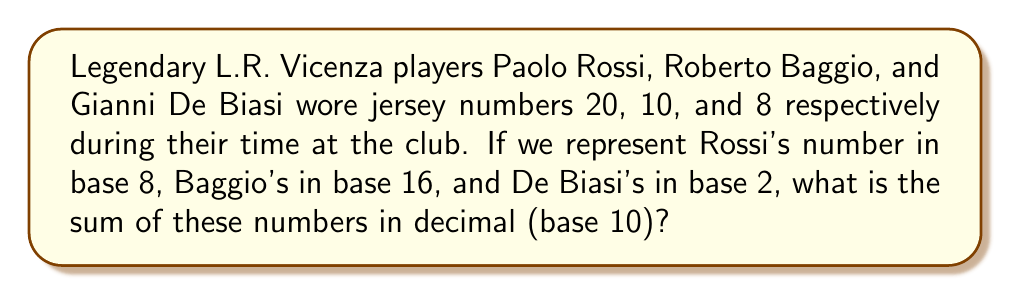Help me with this question. Let's convert each player's jersey number to base 10 and then sum them up:

1. Paolo Rossi's number 20 in base 8:
   $20_8 = 2 \times 8^1 + 0 \times 8^0 = 16_{10}$

2. Roberto Baggio's number 10 in base 16:
   $10_{16} = 1 \times 16^1 + 0 \times 16^0 = 16_{10}$

3. Gianni De Biasi's number 8 in base 2:
   $8_2 = 1000_2 = 1 \times 2^3 + 0 \times 2^2 + 0 \times 2^1 + 0 \times 2^0 = 8_{10}$

Now, we can sum these base 10 numbers:

$$16 + 16 + 8 = 40$$

Therefore, the sum of the jersey numbers in decimal (base 10) is 40.
Answer: $40_{10}$ 